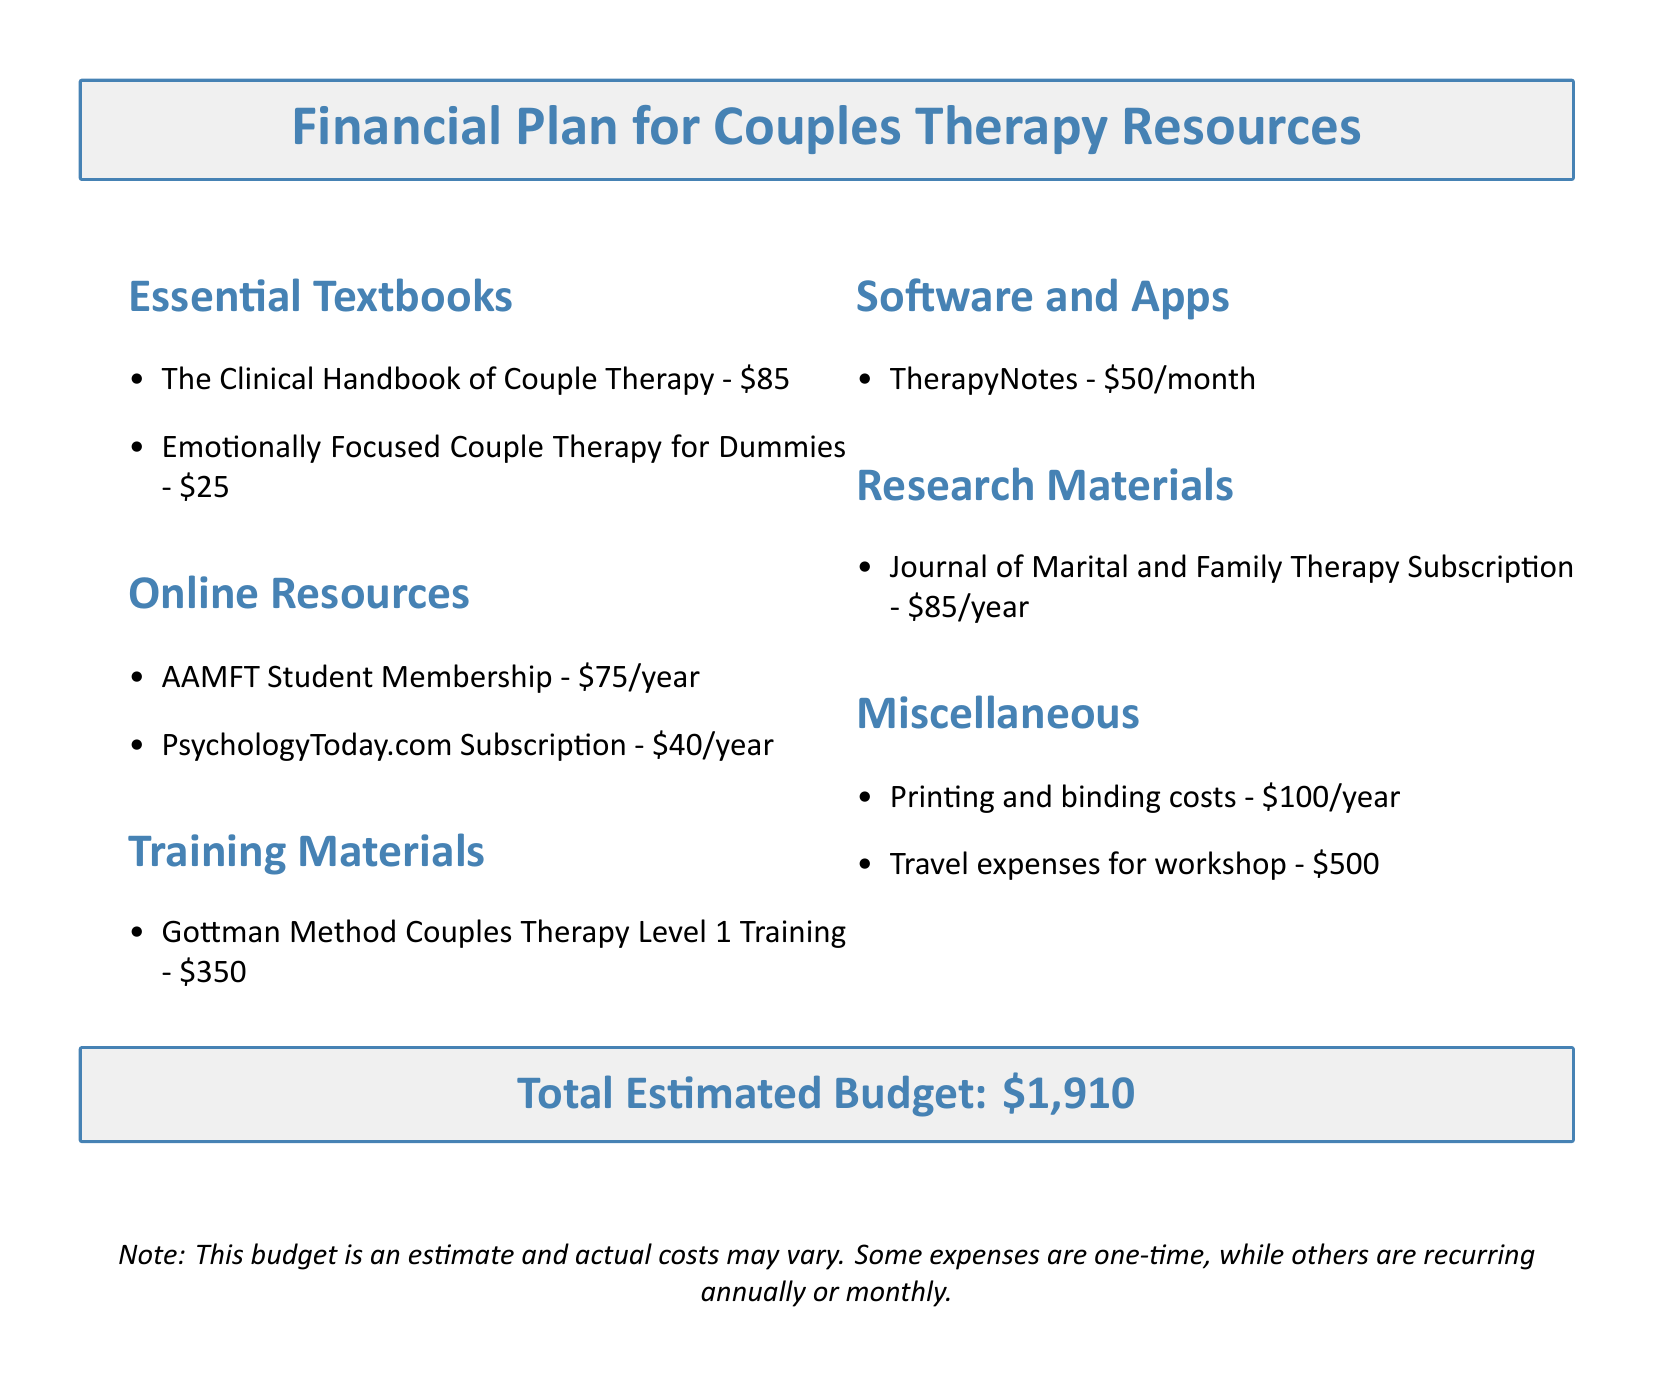What is the total estimated budget? The total estimated budget is clearly stated at the end of the document, which includes all categories of expenses.
Answer: $1,910 How much does the "Gottman Method Couples Therapy Level 1 Training" cost? This cost is specifically listed under the training materials section of the document.
Answer: $350 What is the cost of an AAMFT Student Membership? The membership cost is provided in the online resources section of the budget.
Answer: $75/year How much will the "TherapyNotes" subscription cost annually? Since this is a monthly expense, calculating its annual cost requires multiplying the monthly cost by 12.
Answer: $600/year What is the cost of the "Journal of Marital and Family Therapy Subscription"? This cost is explicitly mentioned in the research materials section of the document.
Answer: $85/year How much money should be allocated for travel expenses for the workshop? The travel expenses are clearly outlined under miscellaneous expenses in the document.
Answer: $500 What is the cost of printing and binding per year? The document indicates the cost for printing and binding in the miscellaneous section.
Answer: $100/year What educational category does "Emotionally Focused Couple Therapy for Dummies" fall under? The textbook is listed under essential textbooks in the document.
Answer: Essential Textbooks 